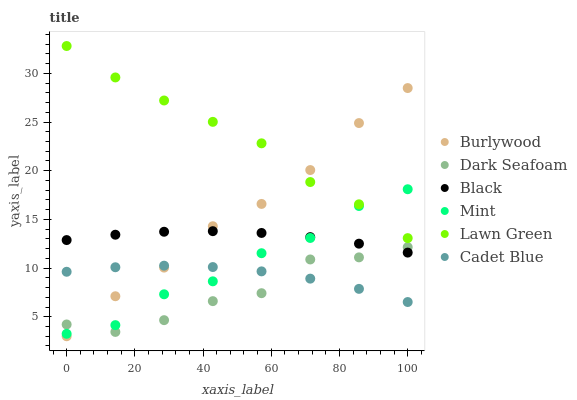Does Dark Seafoam have the minimum area under the curve?
Answer yes or no. Yes. Does Lawn Green have the maximum area under the curve?
Answer yes or no. Yes. Does Cadet Blue have the minimum area under the curve?
Answer yes or no. No. Does Cadet Blue have the maximum area under the curve?
Answer yes or no. No. Is Black the smoothest?
Answer yes or no. Yes. Is Dark Seafoam the roughest?
Answer yes or no. Yes. Is Cadet Blue the smoothest?
Answer yes or no. No. Is Cadet Blue the roughest?
Answer yes or no. No. Does Burlywood have the lowest value?
Answer yes or no. Yes. Does Cadet Blue have the lowest value?
Answer yes or no. No. Does Lawn Green have the highest value?
Answer yes or no. Yes. Does Burlywood have the highest value?
Answer yes or no. No. Is Black less than Lawn Green?
Answer yes or no. Yes. Is Lawn Green greater than Dark Seafoam?
Answer yes or no. Yes. Does Cadet Blue intersect Dark Seafoam?
Answer yes or no. Yes. Is Cadet Blue less than Dark Seafoam?
Answer yes or no. No. Is Cadet Blue greater than Dark Seafoam?
Answer yes or no. No. Does Black intersect Lawn Green?
Answer yes or no. No. 